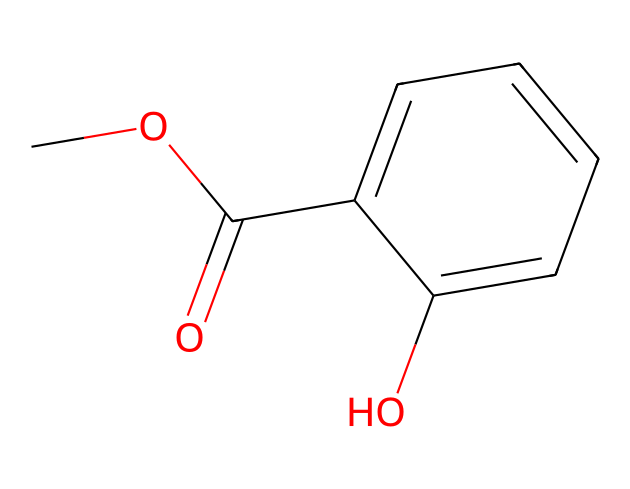What is the common name of this compound? The given SMILES represents methyl salicylate, which is a well-known analgesic compound commonly used in topical pain relievers.
Answer: methyl salicylate How many carbon atoms are in the molecule? By analyzing the provided SMILES, the molecule contains a total of 9 carbon atoms (C). This includes the methyl group, the carbonyl carbon, and the carbons in the aromatic ring.
Answer: 9 What functional groups are present in this compound? The molecule contains an ester functional group (indicated by the C(=O)O part) and a hydroxyl group (the -OH attached to the aromatic ring) as seen from the SMILES representation.
Answer: ester and hydroxyl What is the significance of the -O- (methoxy) group in this chemical? The -O- (methoxy) group enhances the lipophilicity and affects the solubility of the compound, contributing to its absorption in topical formulations, as derived from the structure.
Answer: enhances absorption What type of compound is methyl salicylate primarily classified as? Based on its functional groups and structure, methyl salicylate is primarily classified as an ester due to the ester bond (C(=O)O) linking the methoxy and salicylic acid components.
Answer: ester How does the aromatic ring structure affect the properties of methyl salicylate? The presence of the aromatic ring increases the stability and influences the interaction of the compound with biological targets, as it affects the overall polarity and reactivity of the molecule.
Answer: increases stability and interactiveness 